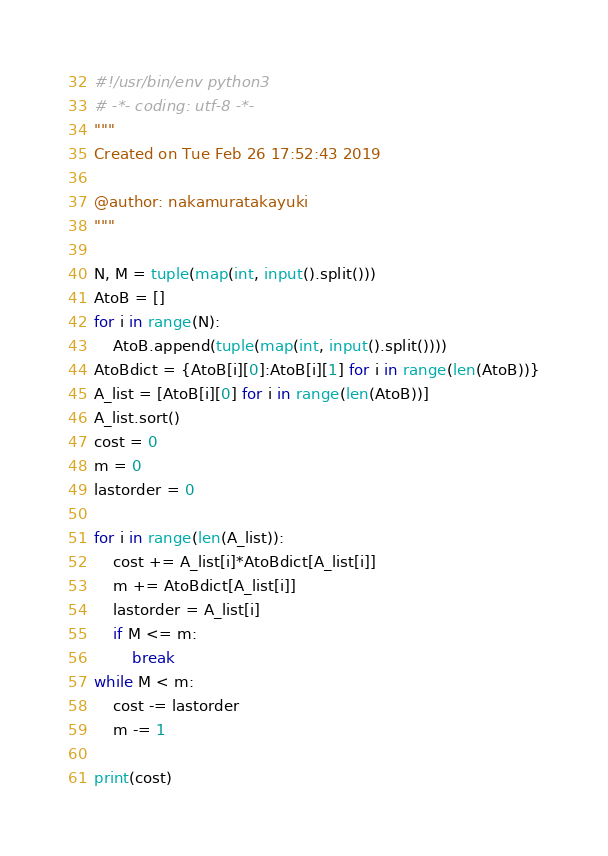Convert code to text. <code><loc_0><loc_0><loc_500><loc_500><_Python_>#!/usr/bin/env python3
# -*- coding: utf-8 -*-
"""
Created on Tue Feb 26 17:52:43 2019

@author: nakamuratakayuki
"""

N, M = tuple(map(int, input().split()))
AtoB = []
for i in range(N):
    AtoB.append(tuple(map(int, input().split())))
AtoBdict = {AtoB[i][0]:AtoB[i][1] for i in range(len(AtoB))}
A_list = [AtoB[i][0] for i in range(len(AtoB))]
A_list.sort()
cost = 0
m = 0
lastorder = 0

for i in range(len(A_list)):
    cost += A_list[i]*AtoBdict[A_list[i]]
    m += AtoBdict[A_list[i]]
    lastorder = A_list[i]
    if M <= m:
        break
while M < m:
    cost -= lastorder
    m -= 1

print(cost)</code> 